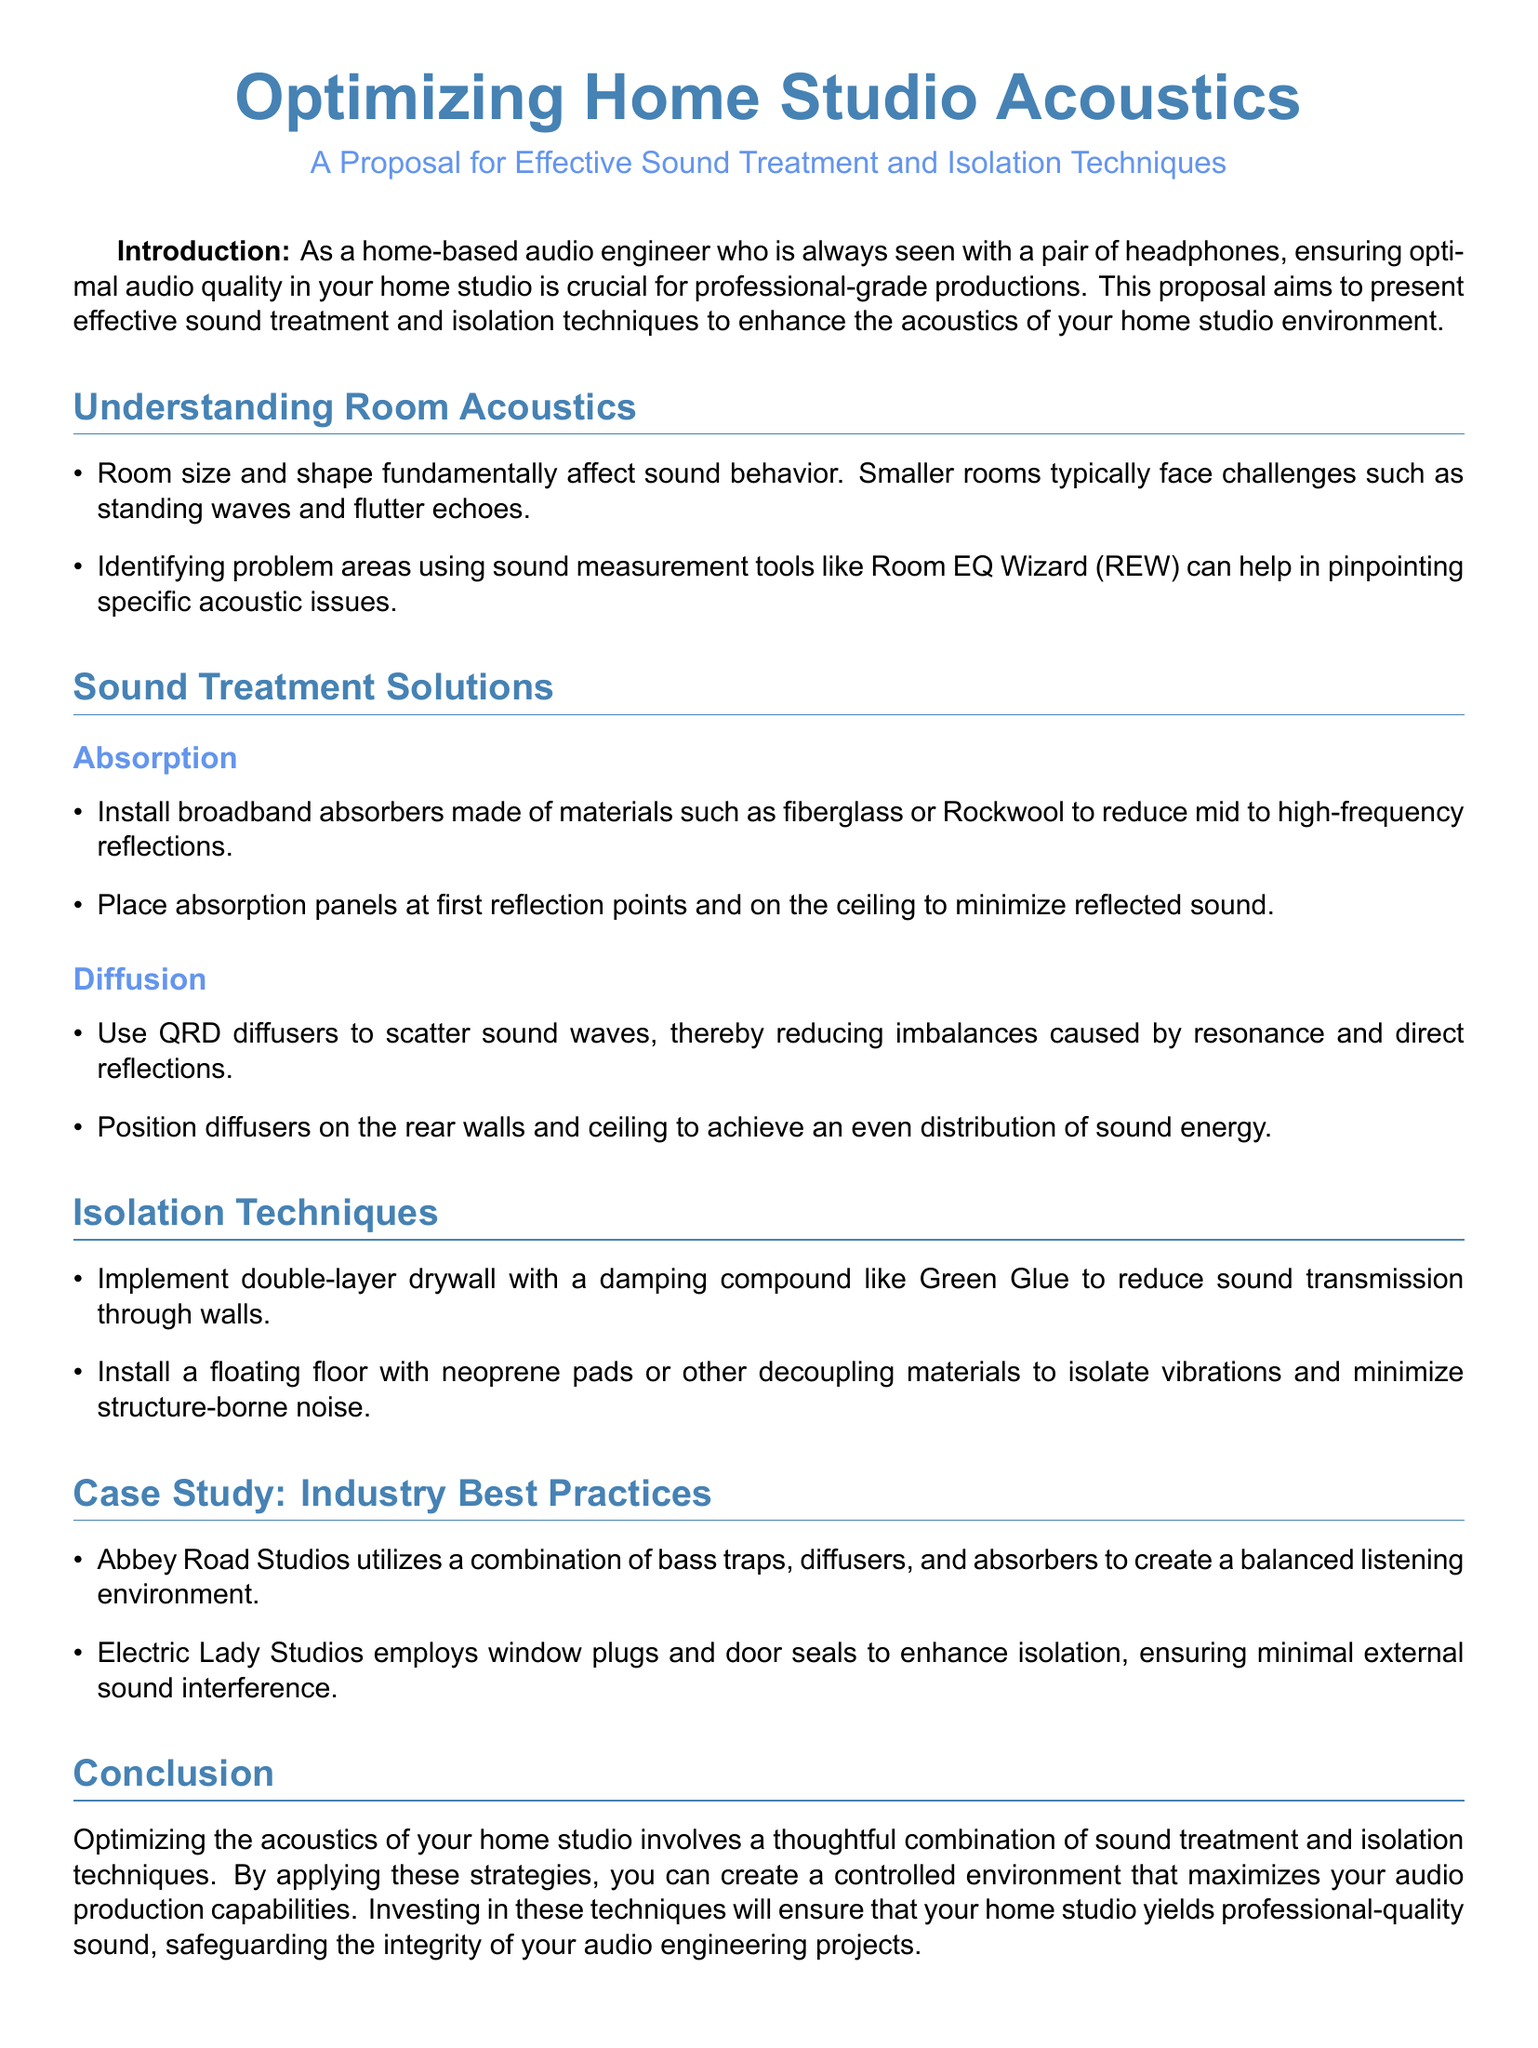What is the proposal about? The proposal focuses on enhancing the acoustics of home studios through effective techniques.
Answer: Optimizing Home Studio Acoustics What measurement tool is mentioned for identifying acoustic issues? The document suggests using a specific tool to pinpoint problems in room acoustics.
Answer: Room EQ Wizard What type of absorbers are recommended for sound treatment? The document lists materials that can be used to create broadband absorbers to improve sound quality.
Answer: Fiberglass or Rockwool Which studios are mentioned as case studies? The document references two well-known studios known for their acoustic treatment practices.
Answer: Abbey Road Studios and Electric Lady Studios What is one isolation technique mentioned? The document highlights a specific construction method to minimize sound transmission.
Answer: Double-layer drywall What frequency range do absorption panels target? The document specifies the frequency range that absorption panels are designed to reduce.
Answer: Mid to high-frequency What component is used in floating floors for isolation? The proposal describes a material that can be used to create a floating floor for better isolation.
Answer: Neoprene pads What is the role of diffusion in sound treatment? The document explains how diffusers work to improve sound distribution in a studio.
Answer: Scattering sound waves What is the main benefit of optimizing acoustics in a home studio? The document states the primary outcome of applying the proposed techniques in a home studio environment.
Answer: Professional-quality sound 